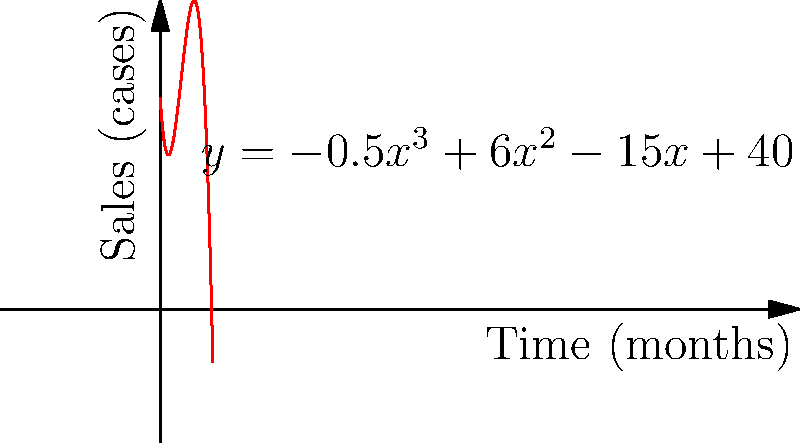As a restaurant owner offering organic and biodynamic wines, you've been tracking the sales of a particular wine over the past 10 months. The sales trend can be modeled by the polynomial function $y = -0.5x^3 + 6x^2 - 15x + 40$, where $y$ represents the number of cases sold and $x$ represents the number of months since you started tracking. At what month does the sales trend reach its peak? To find the peak of the sales trend, we need to follow these steps:

1) The peak occurs at the maximum point of the function, which can be found where the derivative of the function equals zero.

2) Let's find the derivative of $y = -0.5x^3 + 6x^2 - 15x + 40$:
   $y' = -1.5x^2 + 12x - 15$

3) Set the derivative equal to zero:
   $-1.5x^2 + 12x - 15 = 0$

4) This is a quadratic equation. We can solve it using the quadratic formula:
   $x = \frac{-b \pm \sqrt{b^2 - 4ac}}{2a}$

   Where $a = -1.5$, $b = 12$, and $c = -15$

5) Plugging in these values:
   $x = \frac{-12 \pm \sqrt{12^2 - 4(-1.5)(-15)}}{2(-1.5)}$
   $= \frac{-12 \pm \sqrt{144 - 90}}{-3}$
   $= \frac{-12 \pm \sqrt{54}}{-3}$
   $= \frac{-12 \pm 3\sqrt{6}}{-3}$

6) This gives us two solutions:
   $x_1 = \frac{-12 + 3\sqrt{6}}{-3} = 4 - \sqrt{6}$
   $x_2 = \frac{-12 - 3\sqrt{6}}{-3} = 4 + \sqrt{6}$

7) Since we're looking for the maximum (peak), we choose the larger value: $4 + \sqrt{6}$

8) This value is approximately 6.45 months.

Therefore, the sales trend reaches its peak at approximately 6.45 months.
Answer: 6.45 months 